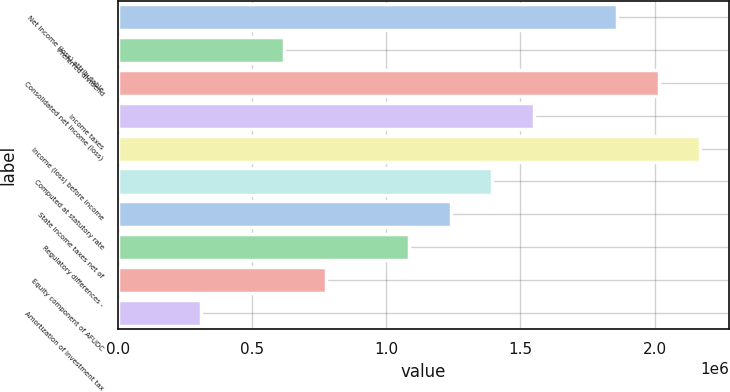<chart> <loc_0><loc_0><loc_500><loc_500><bar_chart><fcel>Net income (loss) attributable<fcel>Preferred dividend<fcel>Consolidated net income (loss)<fcel>Income taxes<fcel>Income (loss) before income<fcel>Computed at statutory rate<fcel>State income taxes net of<fcel>Regulatory differences -<fcel>Equity component of AFUDC<fcel>Amortization of investment tax<nl><fcel>1.85982e+06<fcel>619964<fcel>2.0148e+06<fcel>1.54985e+06<fcel>2.16978e+06<fcel>1.39487e+06<fcel>1.23989e+06<fcel>1.08491e+06<fcel>774946<fcel>310001<nl></chart> 